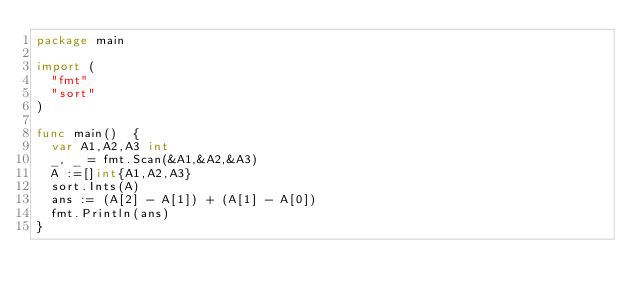<code> <loc_0><loc_0><loc_500><loc_500><_Go_>package main

import (
	"fmt"
	"sort"
)

func main()  {
	var A1,A2,A3 int
	_, _ = fmt.Scan(&A1,&A2,&A3)
	A :=[]int{A1,A2,A3}
	sort.Ints(A)
	ans := (A[2] - A[1]) + (A[1] - A[0])
	fmt.Println(ans)
}
</code> 